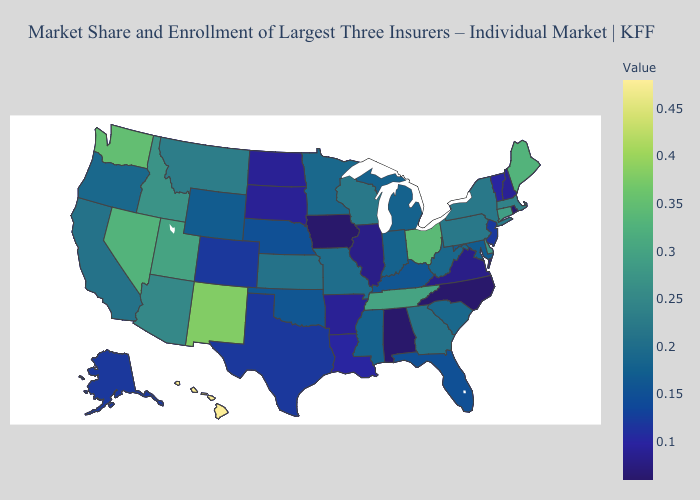Among the states that border Pennsylvania , does Delaware have the lowest value?
Short answer required. No. Among the states that border Iowa , does South Dakota have the highest value?
Write a very short answer. No. Which states hav the highest value in the Northeast?
Quick response, please. Maine. 